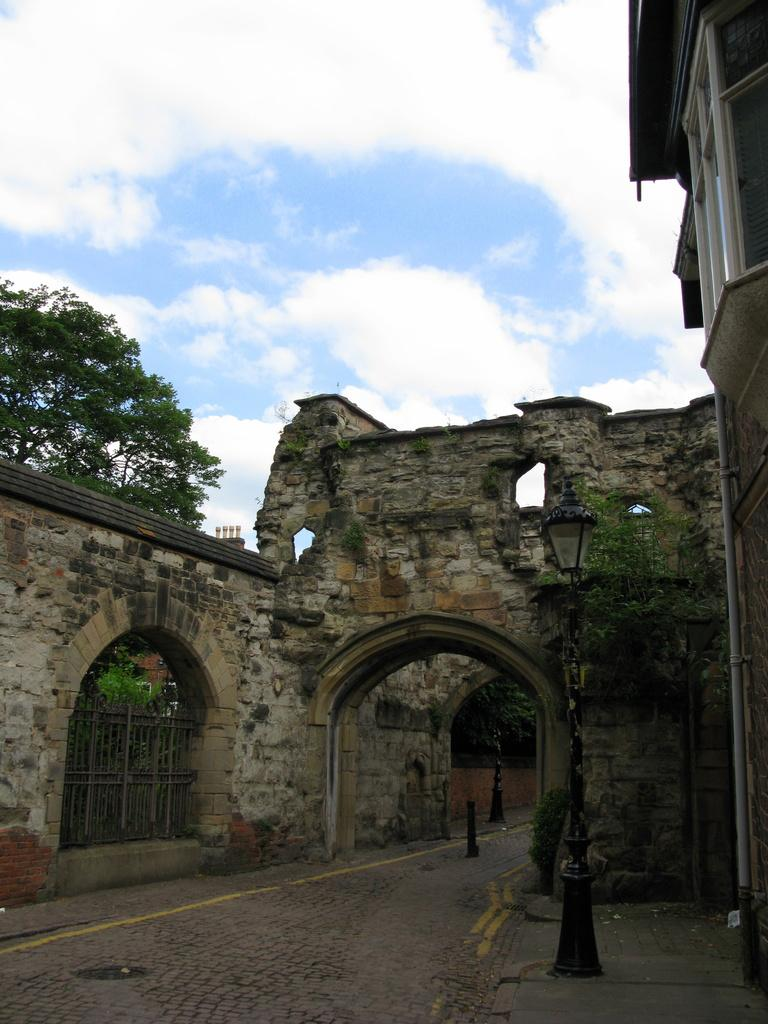What type of structure is present in the image? There is a building in the image. What can be seen attached to the building? There are lights and poles in the image. What type of vegetation is present in the image? There are trees in the image. What is visible in the background of the image? The sky is visible in the background of the image. What type of joke is being told by the trees in the image? There are no jokes being told in the image, as trees do not have the ability to communicate or tell jokes. 